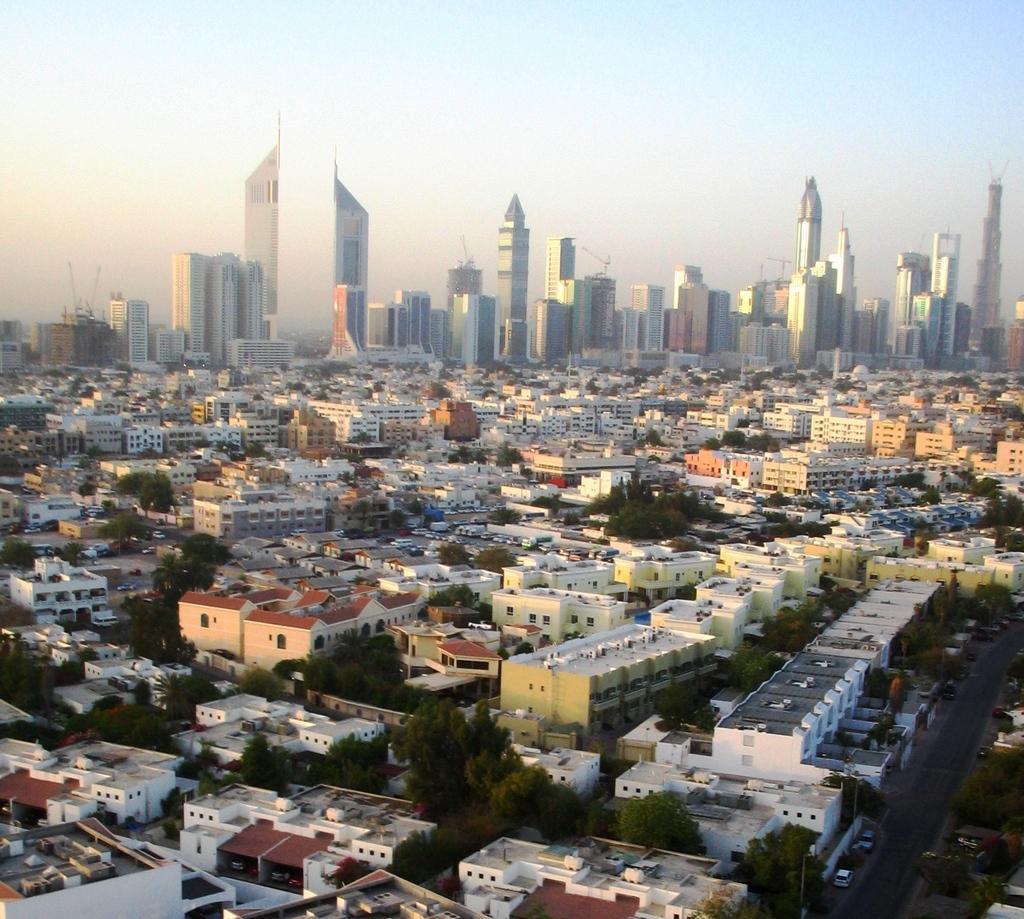In one or two sentences, can you explain what this image depicts? In this image we can see buildings,trees,road. At the top of the image there is sky. 